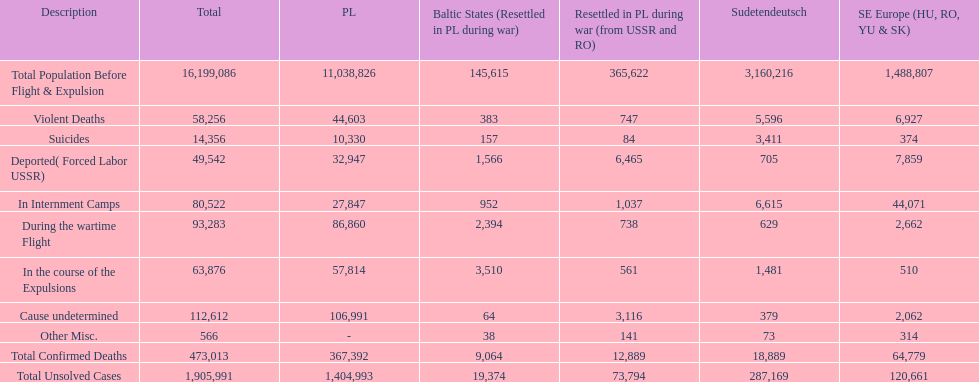Was there a larger total population before expulsion in poland or sudetendeutsch? Poland. 